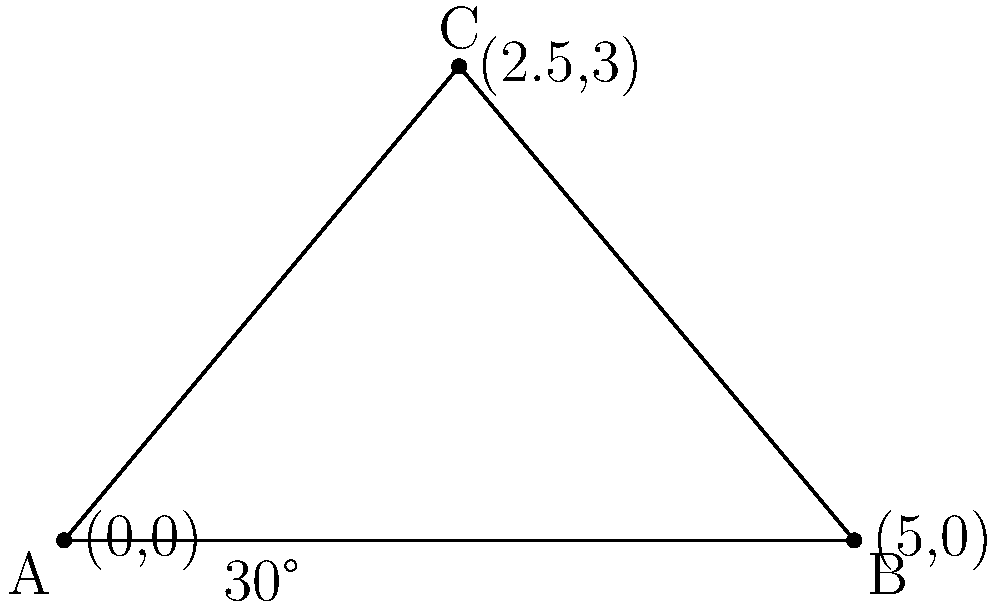In setting up a temporary bridge across a small ravine, you need to determine the safest angle for the support structure. If the bridge spans 5 meters and the support beam forms a 30° angle with the horizontal, what is the optimal angle (in degrees) between the two support beams to ensure maximum stability? Let's approach this step-by-step:

1) The bridge forms an isosceles triangle with the ground and two support beams.

2) We know that one of the angles at the base is 30°.

3) In an isosceles triangle, the base angles are equal. So both base angles are 30°.

4) The sum of angles in a triangle is always 180°.

5) Let's call the angle between the support beams $x$.

6) We can set up an equation:
   $$30° + 30° + x = 180°$$

7) Simplify:
   $$60° + x = 180°$$

8) Solve for $x$:
   $$x = 180° - 60° = 120°$$

Therefore, the optimal angle between the two support beams for maximum stability is 120°.
Answer: 120° 